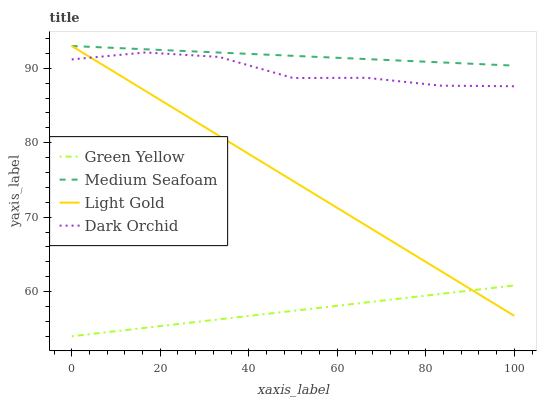Does Green Yellow have the minimum area under the curve?
Answer yes or no. Yes. Does Medium Seafoam have the maximum area under the curve?
Answer yes or no. Yes. Does Light Gold have the minimum area under the curve?
Answer yes or no. No. Does Light Gold have the maximum area under the curve?
Answer yes or no. No. Is Medium Seafoam the smoothest?
Answer yes or no. Yes. Is Dark Orchid the roughest?
Answer yes or no. Yes. Is Light Gold the smoothest?
Answer yes or no. No. Is Light Gold the roughest?
Answer yes or no. No. Does Green Yellow have the lowest value?
Answer yes or no. Yes. Does Light Gold have the lowest value?
Answer yes or no. No. Does Medium Seafoam have the highest value?
Answer yes or no. Yes. Does Dark Orchid have the highest value?
Answer yes or no. No. Is Green Yellow less than Medium Seafoam?
Answer yes or no. Yes. Is Dark Orchid greater than Green Yellow?
Answer yes or no. Yes. Does Green Yellow intersect Light Gold?
Answer yes or no. Yes. Is Green Yellow less than Light Gold?
Answer yes or no. No. Is Green Yellow greater than Light Gold?
Answer yes or no. No. Does Green Yellow intersect Medium Seafoam?
Answer yes or no. No. 